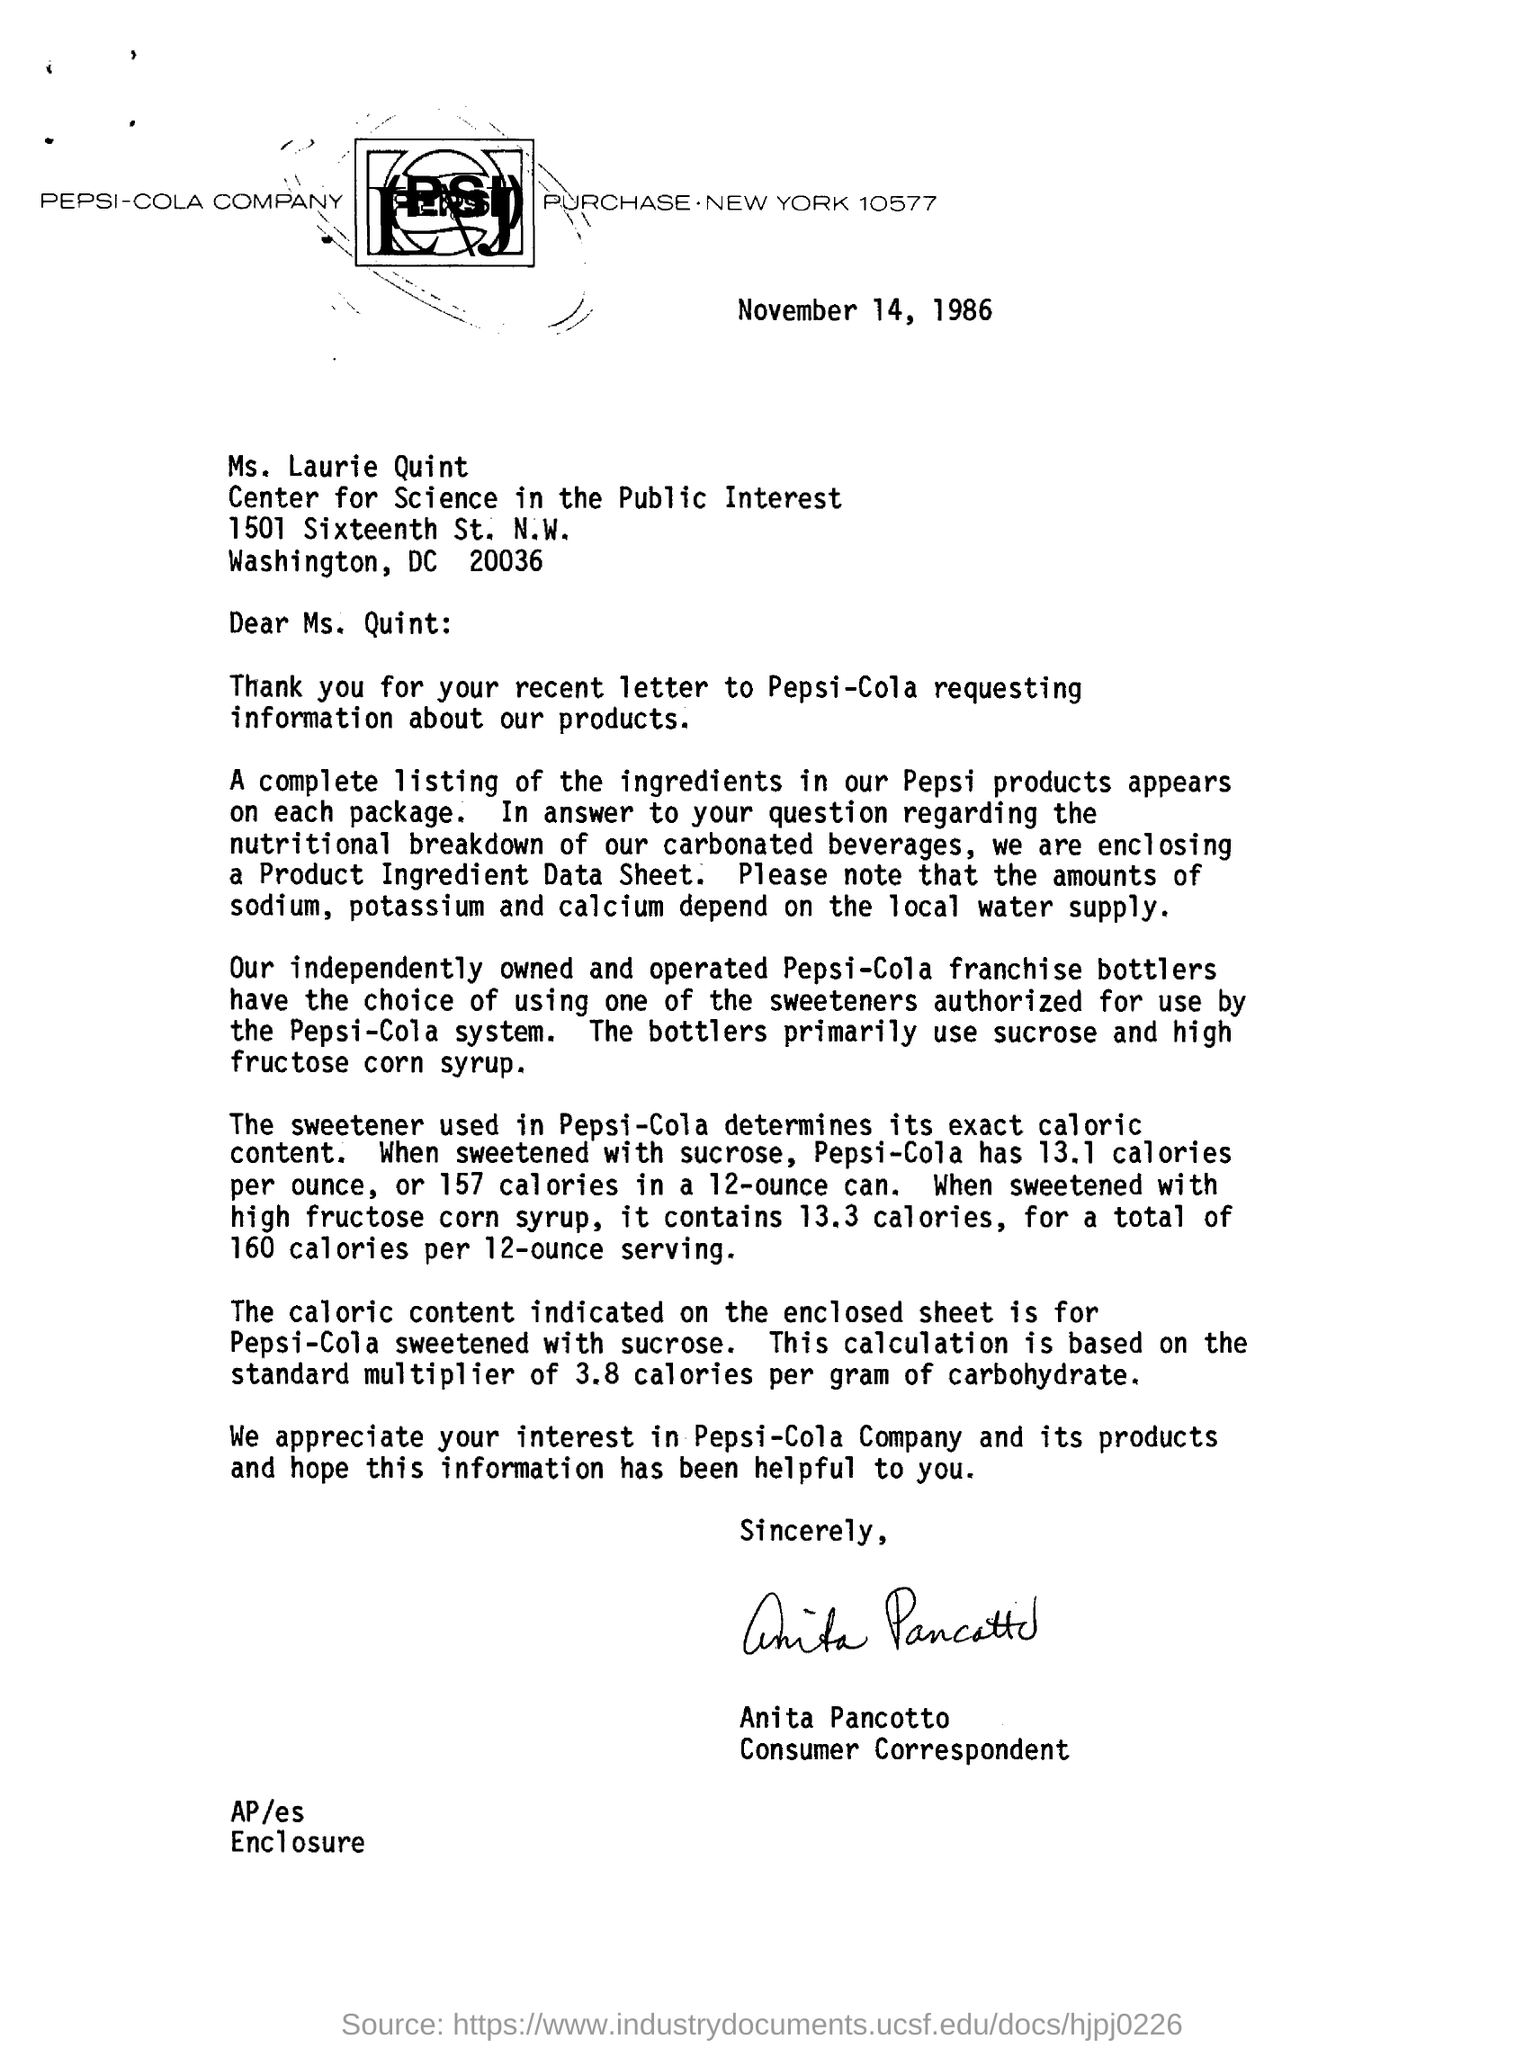What is the date mentioned at the top of the page?
Provide a succinct answer. November 14, 1986. Who is the consumer correspondent?
Give a very brief answer. Anita Pancotto. 